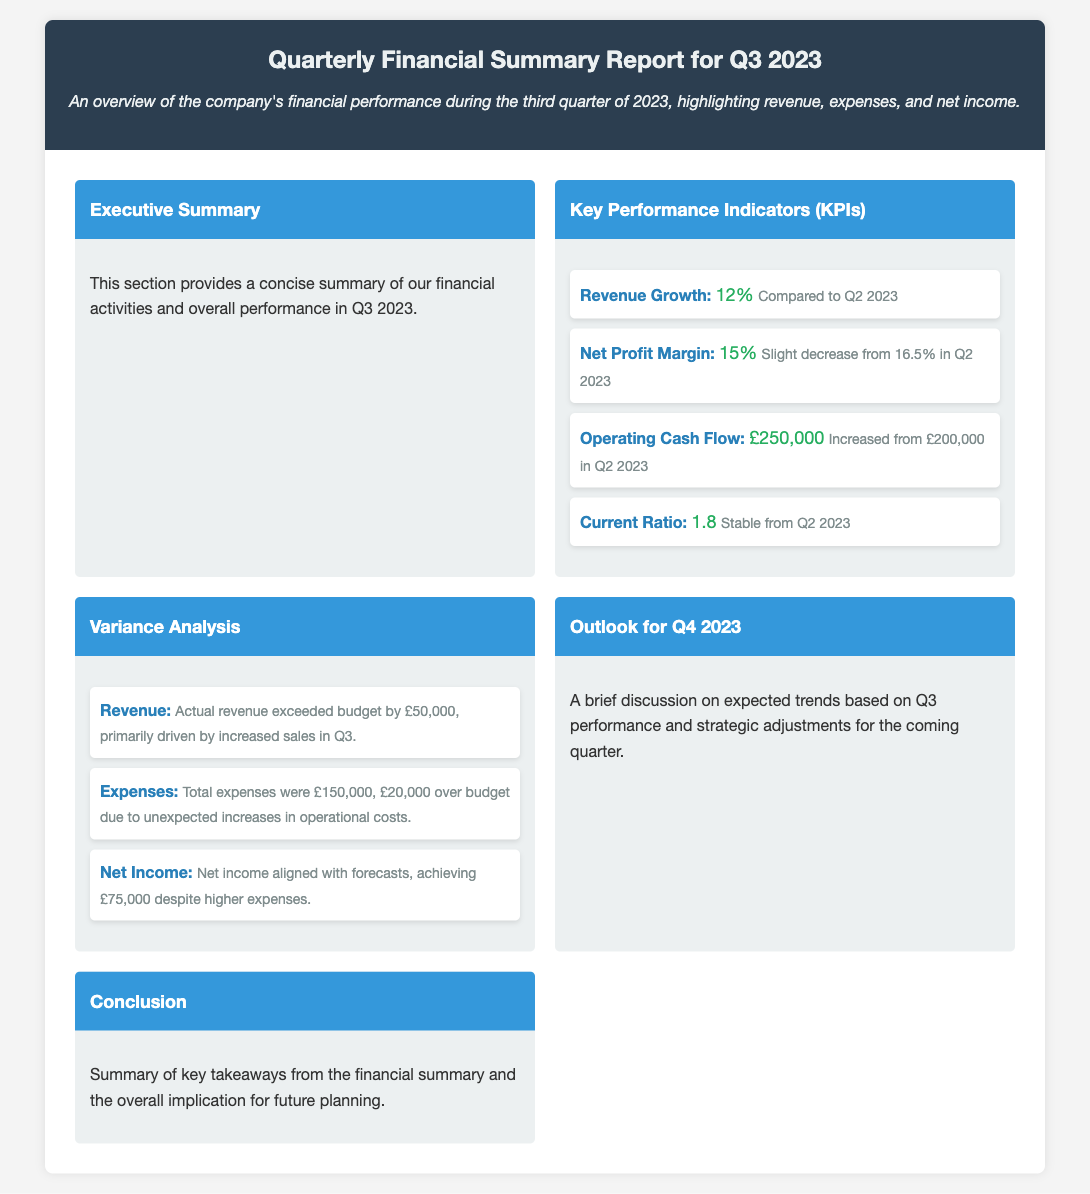What was the revenue growth percentage in Q3 2023? The document states that the revenue growth for Q3 2023 was 12%.
Answer: 12% What was the net profit margin in Q2 2023? The document indicates that the net profit margin was 16.5% in Q2 2023.
Answer: 16.5% How much did the actual revenue exceed the budget by? According to the variance analysis, actual revenue exceeded the budget by £50,000.
Answer: £50,000 What was the total expenses for Q3 2023? The document specifies that total expenses for Q3 2023 were £150,000.
Answer: £150,000 What is the operating cash flow for Q3 2023? Operating cash flow for Q3 2023 is stated as £250,000 in the KPIs section.
Answer: £250,000 Was the current ratio stable or did it change in Q3 2023? The current ratio is described as stable from Q2 2023.
Answer: Stable Which section discusses the expected trends for Q4 2023? The section titled "Outlook for Q4 2023" covers expected trends based on Q3 performance.
Answer: Outlook for Q4 2023 What was the net income achieved in Q3 2023? The document reports that net income achieved was £75,000 in Q3 2023.
Answer: £75,000 What was the unexpected cause for higher expenses in Q3 2023? The document mentions that expenses were £20,000 over budget due to unexpected increases in operational costs.
Answer: Unexpected increases in operational costs 